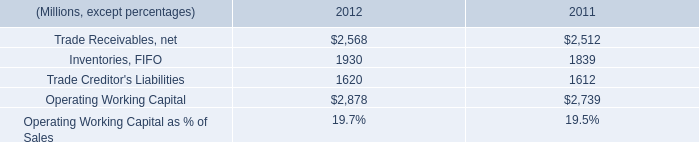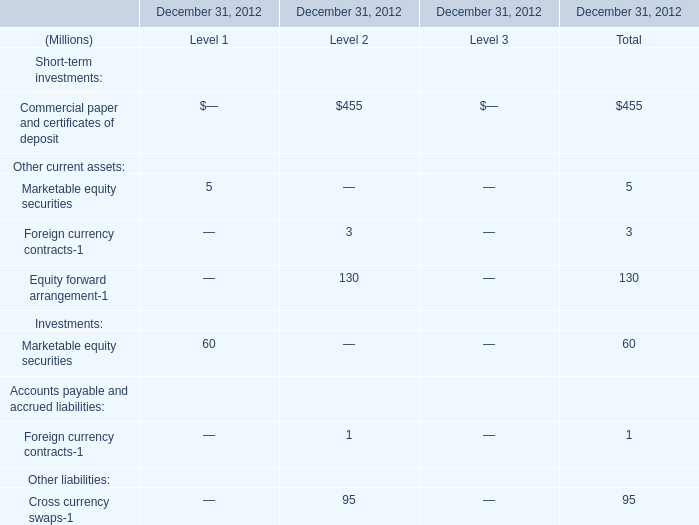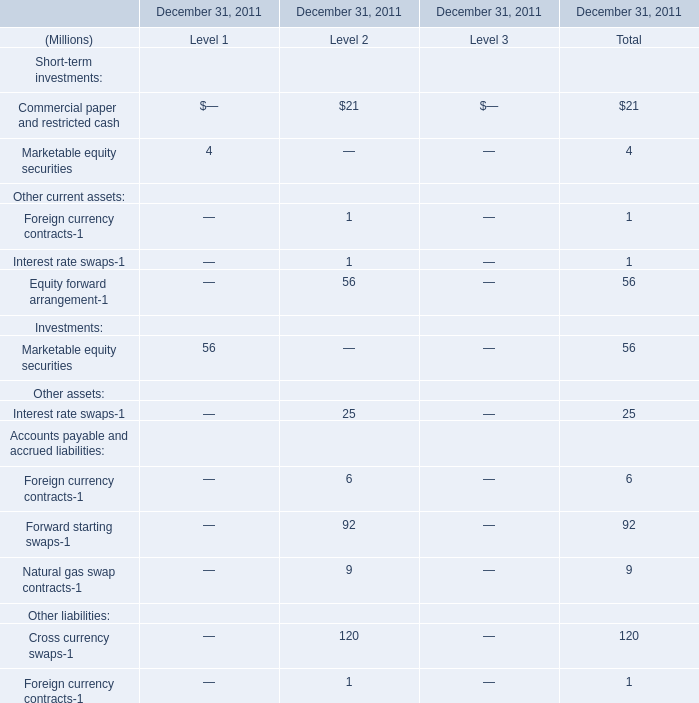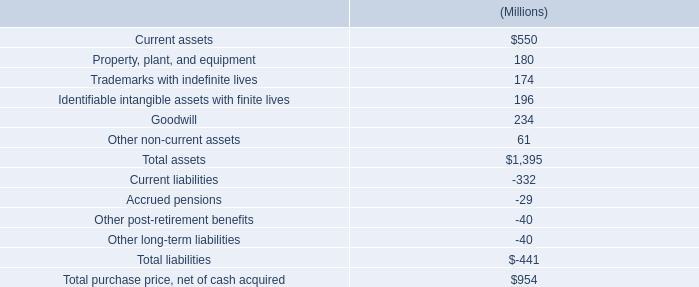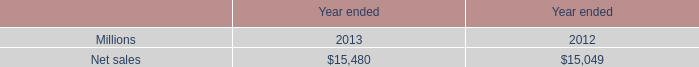what was the difference in millions of capital spending related to business acquisitions from 2011 to 2012? 
Computations: (56 - 34)
Answer: 22.0. 